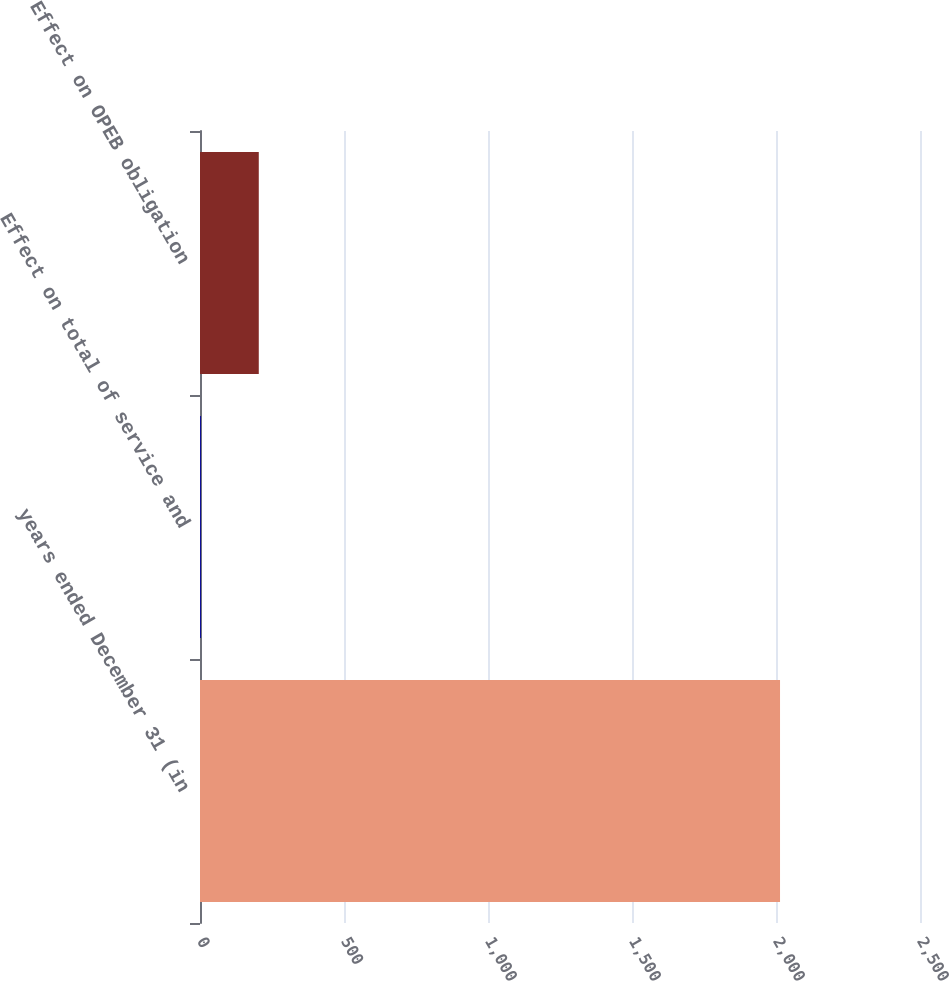Convert chart. <chart><loc_0><loc_0><loc_500><loc_500><bar_chart><fcel>years ended December 31 (in<fcel>Effect on total of service and<fcel>Effect on OPEB obligation<nl><fcel>2014<fcel>3<fcel>204.1<nl></chart> 